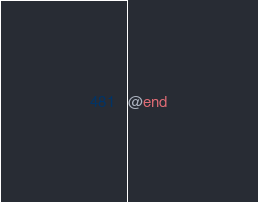Convert code to text. <code><loc_0><loc_0><loc_500><loc_500><_C_>
@end
</code> 